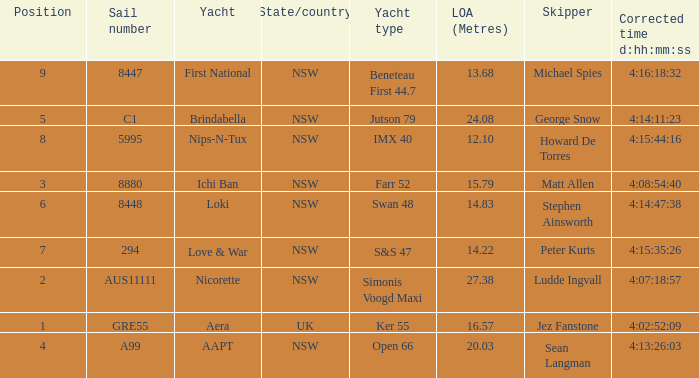What is the ranking for NSW open 66 racing boat.  4.0. 